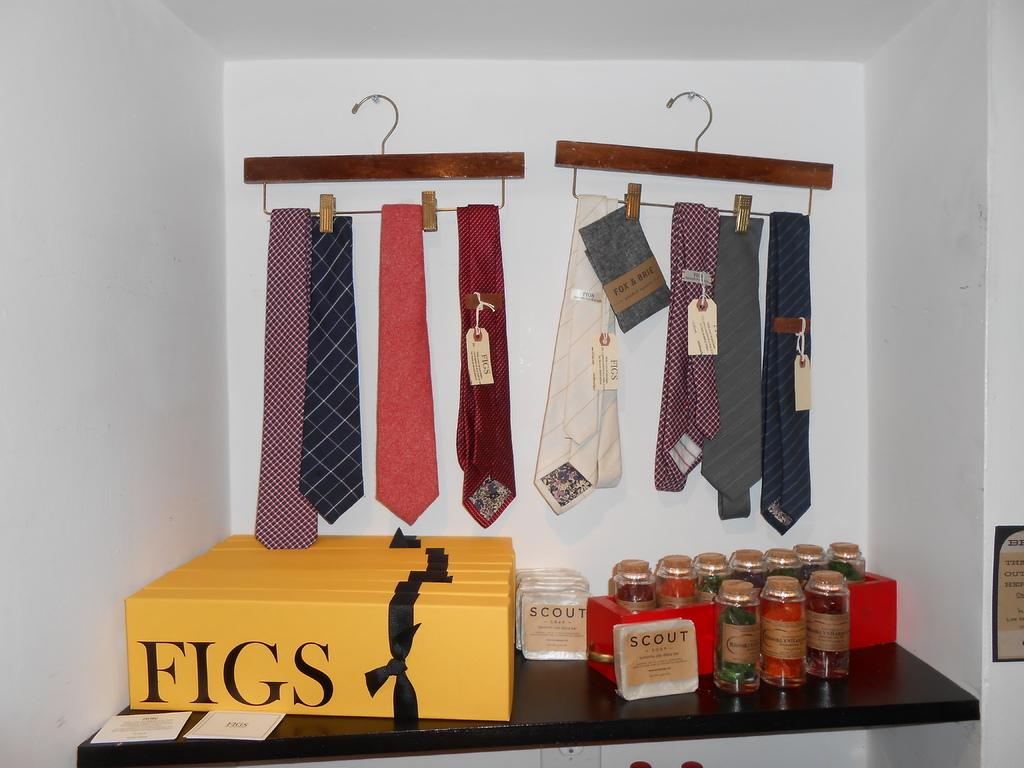<image>
Render a clear and concise summary of the photo. A closet space with yellow boxes with the words FIGS on it and ties hanging on hangers 